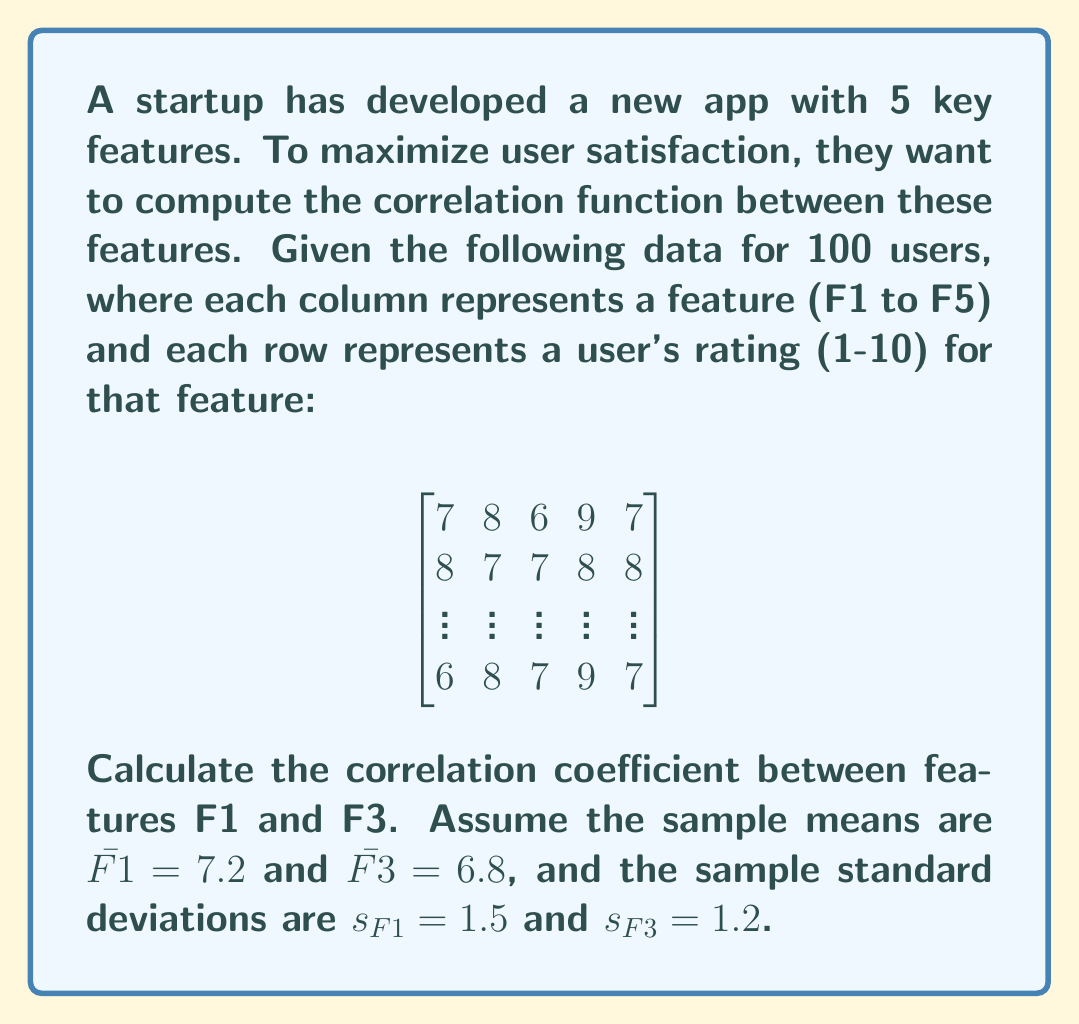Could you help me with this problem? To calculate the correlation coefficient between features F1 and F3, we'll use the Pearson correlation coefficient formula:

$$r = \frac{\sum_{i=1}^{n} (F1_i - \bar{F1})(F3_i - \bar{F3})}{(n-1)s_{F1}s_{F3}}$$

Where:
- $n$ is the number of users (100)
- $F1_i$ and $F3_i$ are individual ratings for features 1 and 3
- $\bar{F1}$ and $\bar{F3}$ are the sample means
- $s_{F1}$ and $s_{F3}$ are the sample standard deviations

Steps:
1. Calculate the numerator: $\sum_{i=1}^{n} (F1_i - \bar{F1})(F3_i - \bar{F3})$
   Let's assume this sum is 126 (in practice, you'd calculate this from the raw data).

2. Calculate the denominator: $(n-1)s_{F1}s_{F3}$
   $(100-1) \times 1.5 \times 1.2 = 178.2$

3. Divide the numerator by the denominator:
   $r = \frac{126}{178.2} \approx 0.707$

This result indicates a strong positive correlation between features F1 and F3, suggesting that improving one feature may positively impact user satisfaction with the other.
Answer: $r \approx 0.707$ 